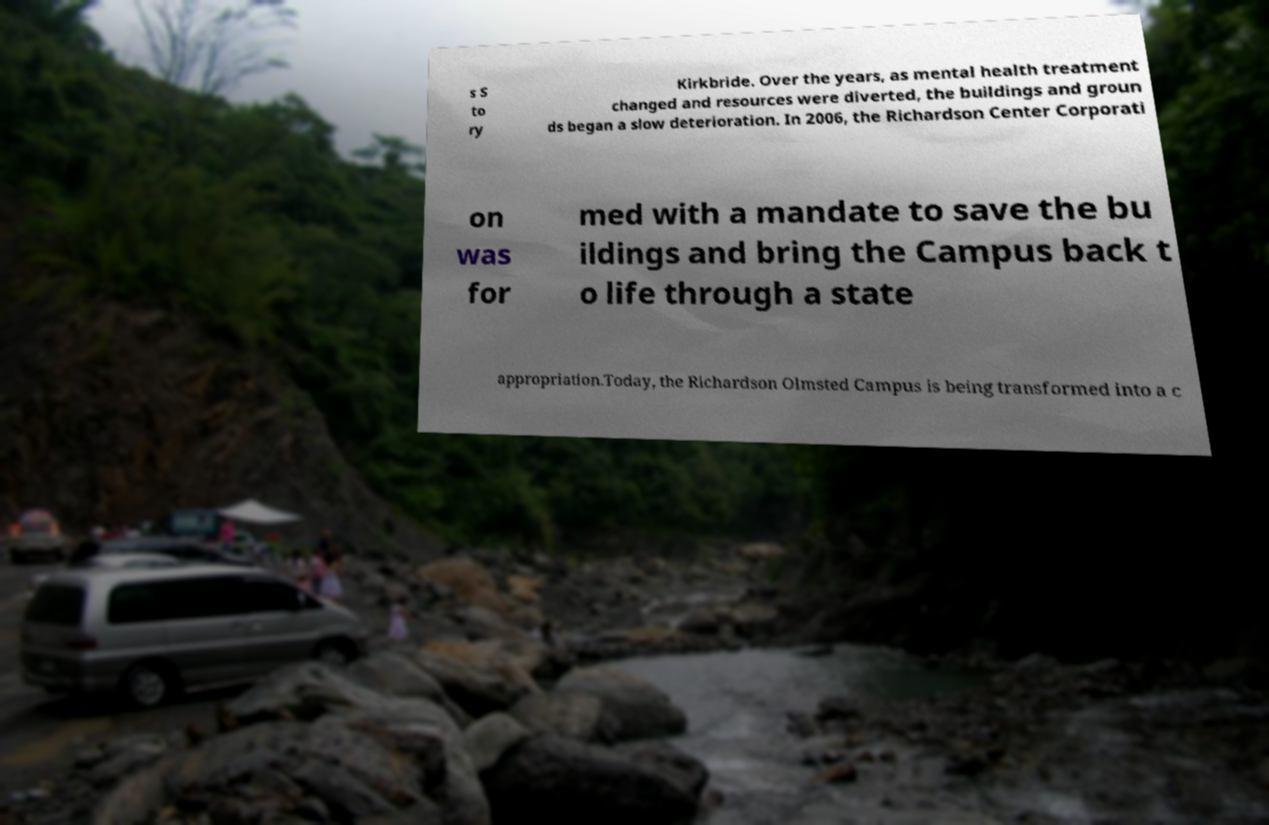There's text embedded in this image that I need extracted. Can you transcribe it verbatim? s S to ry Kirkbride. Over the years, as mental health treatment changed and resources were diverted, the buildings and groun ds began a slow deterioration. In 2006, the Richardson Center Corporati on was for med with a mandate to save the bu ildings and bring the Campus back t o life through a state appropriation.Today, the Richardson Olmsted Campus is being transformed into a c 